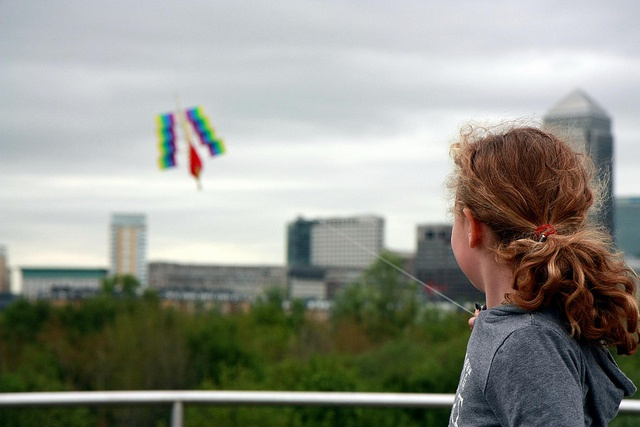Describe the objects in this image and their specific colors. I can see people in darkgray, black, maroon, gray, and brown tones and kite in darkgray, lightgray, tan, and blue tones in this image. 